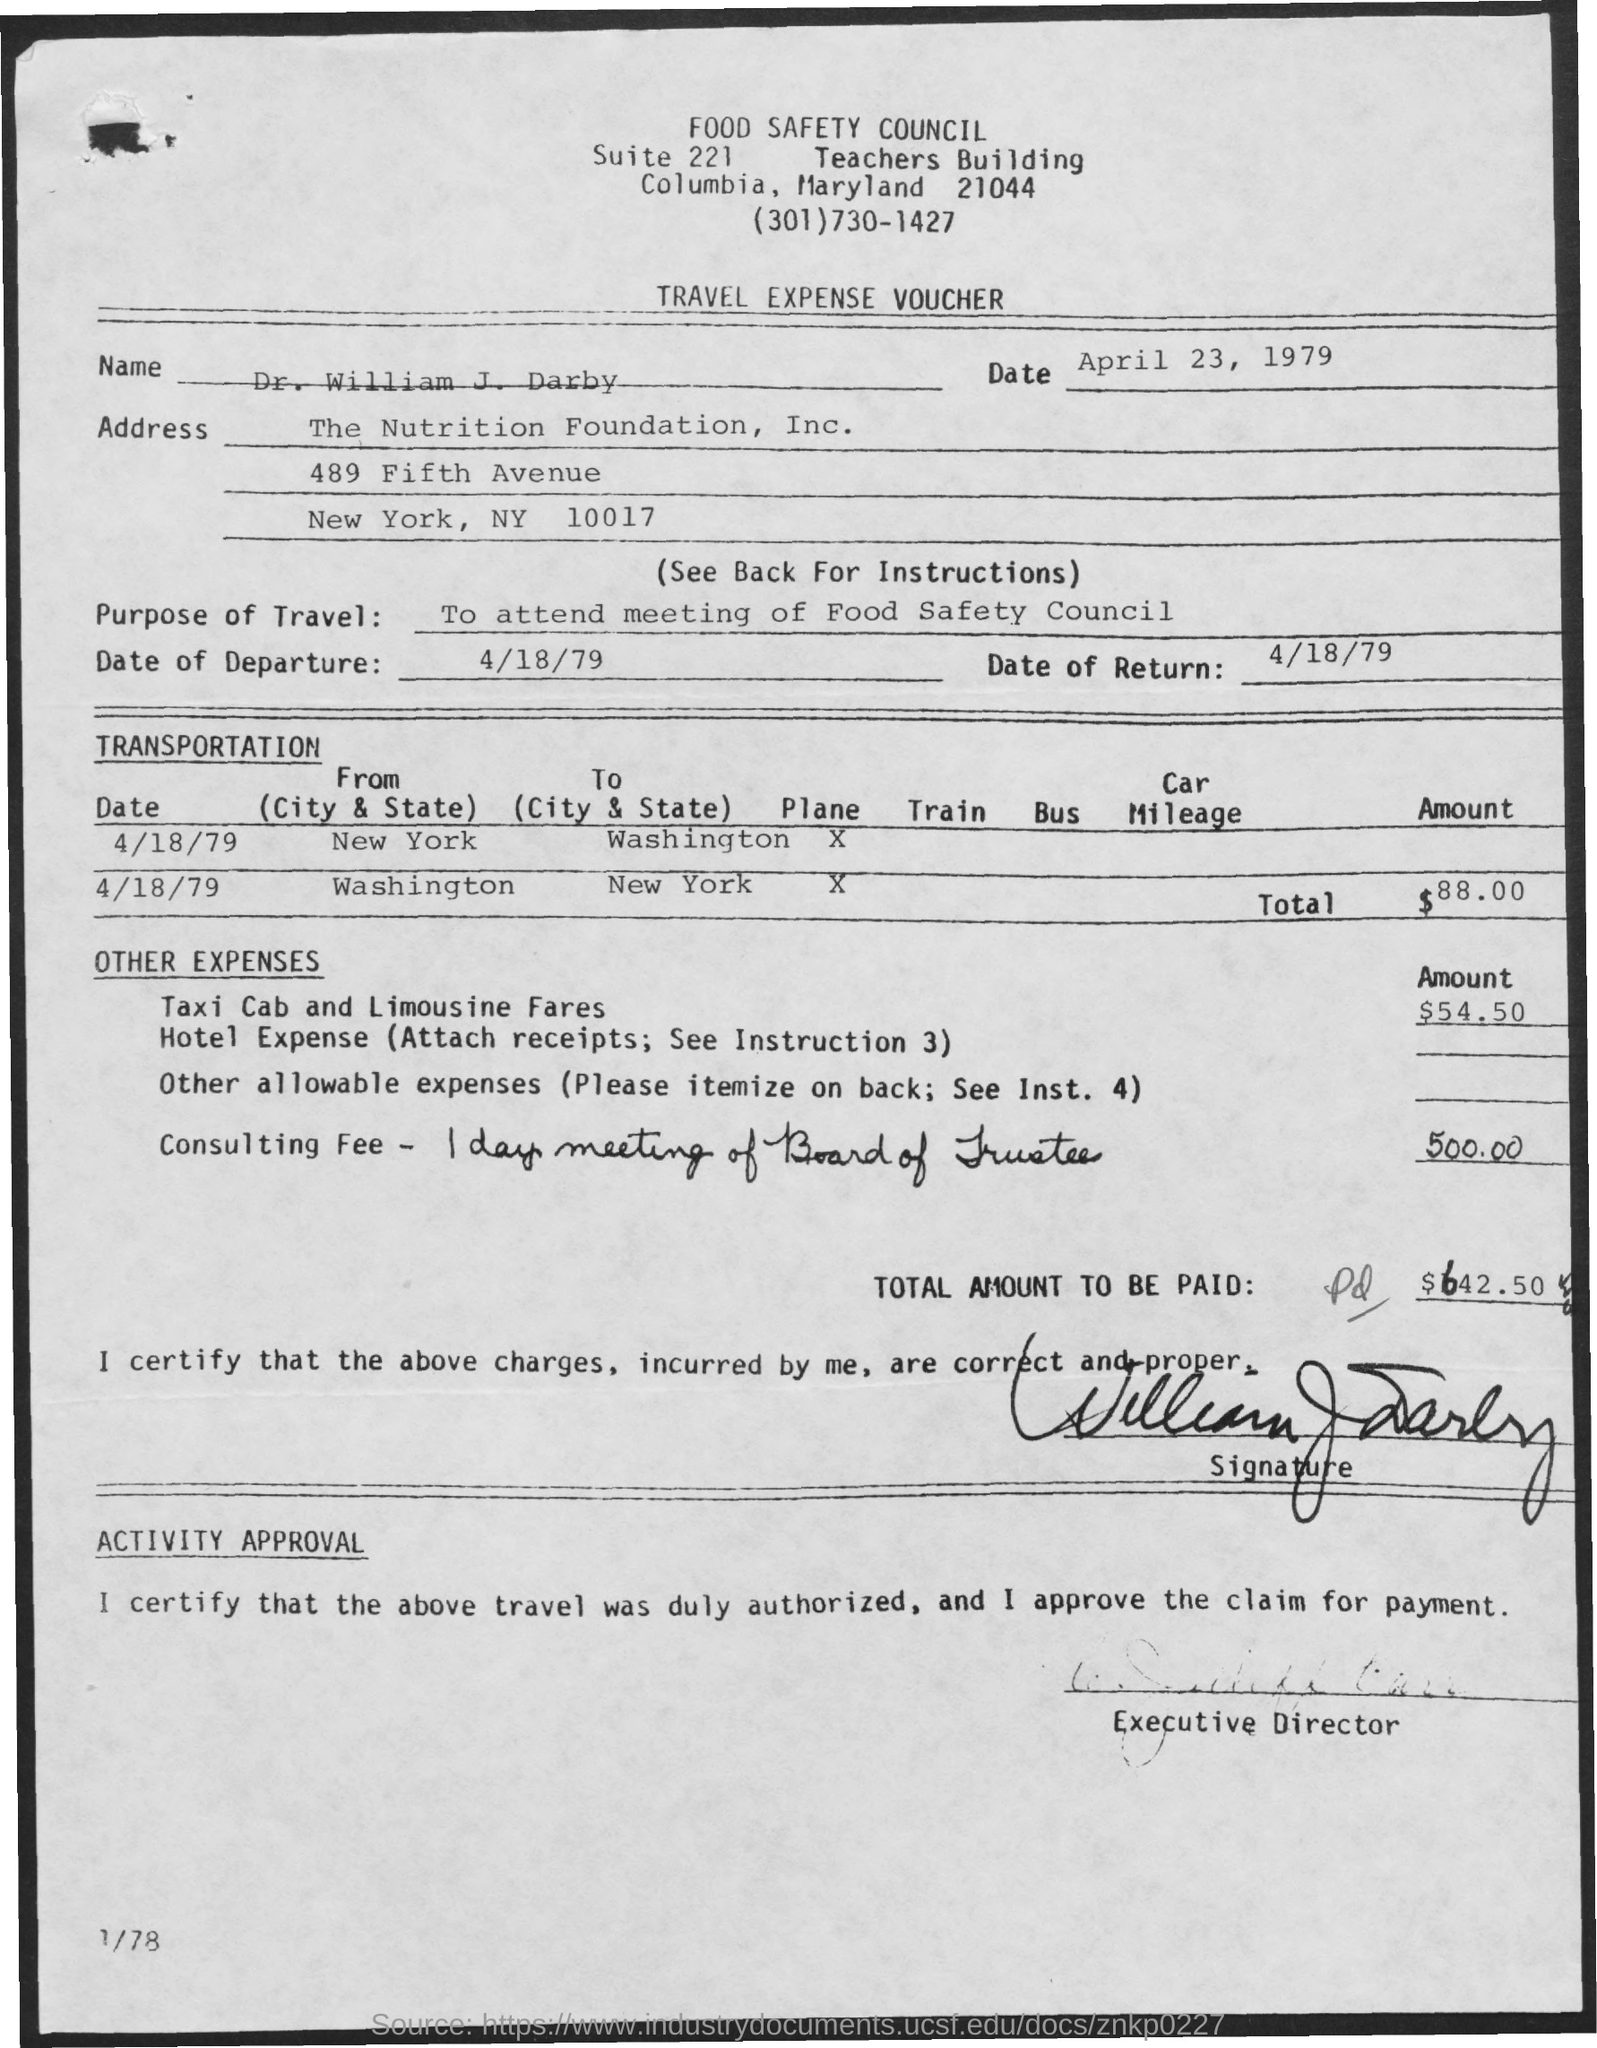What is the Return Date ?
 4/18/79 